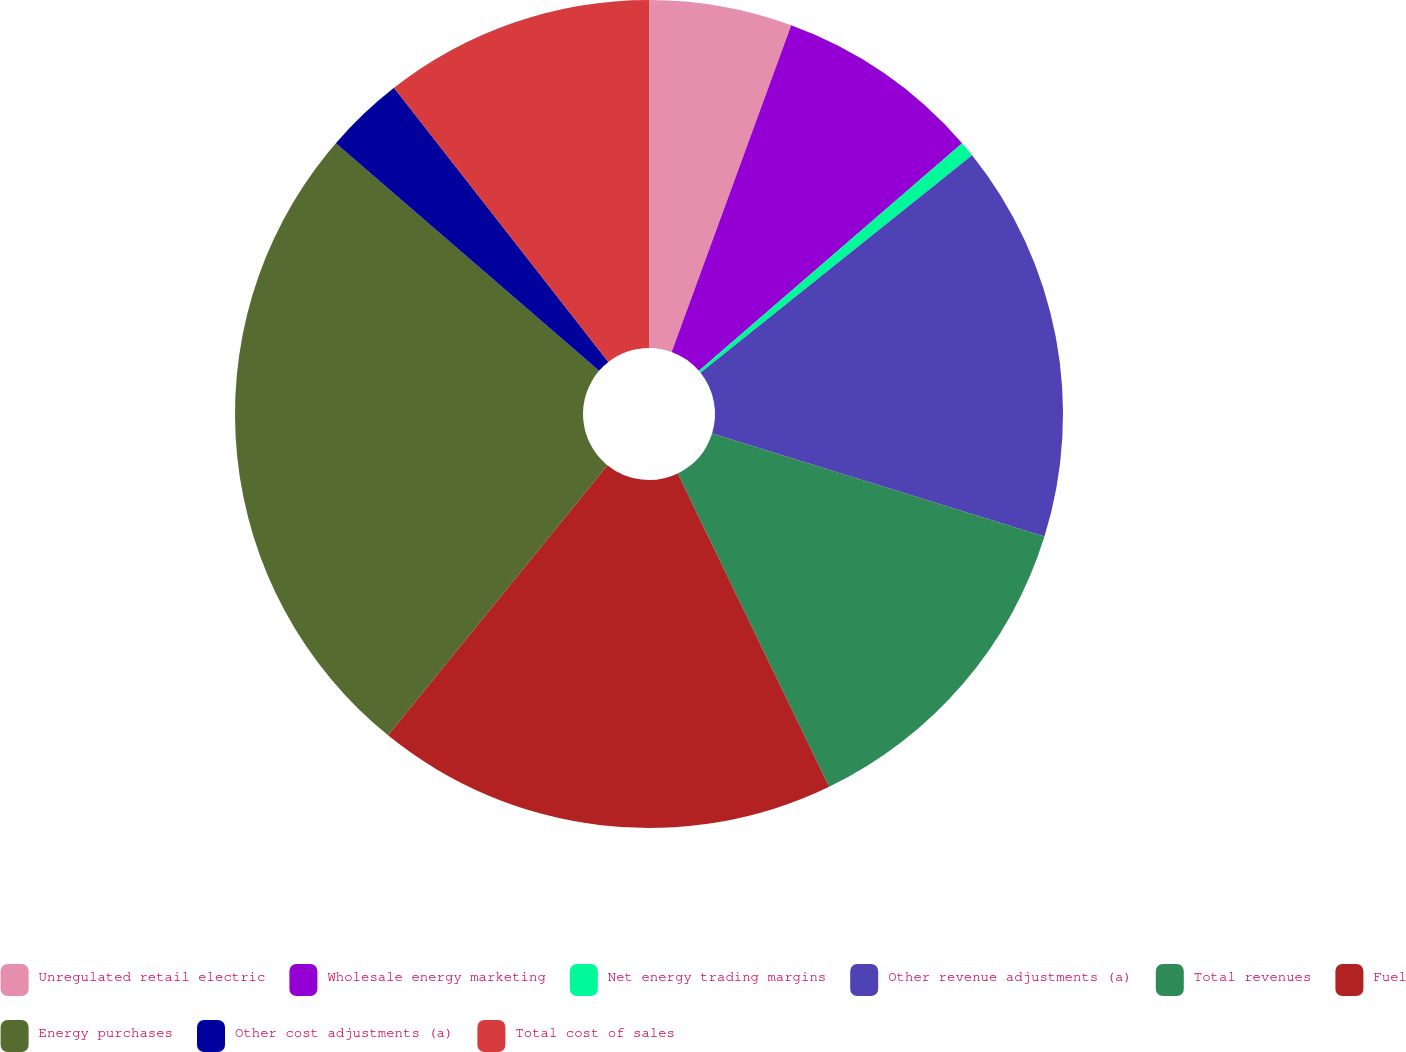Convert chart. <chart><loc_0><loc_0><loc_500><loc_500><pie_chart><fcel>Unregulated retail electric<fcel>Wholesale energy marketing<fcel>Net energy trading margins<fcel>Other revenue adjustments (a)<fcel>Total revenues<fcel>Fuel<fcel>Energy purchases<fcel>Other cost adjustments (a)<fcel>Total cost of sales<nl><fcel>5.58%<fcel>8.07%<fcel>0.6%<fcel>15.53%<fcel>13.05%<fcel>18.02%<fcel>25.49%<fcel>3.09%<fcel>10.56%<nl></chart> 